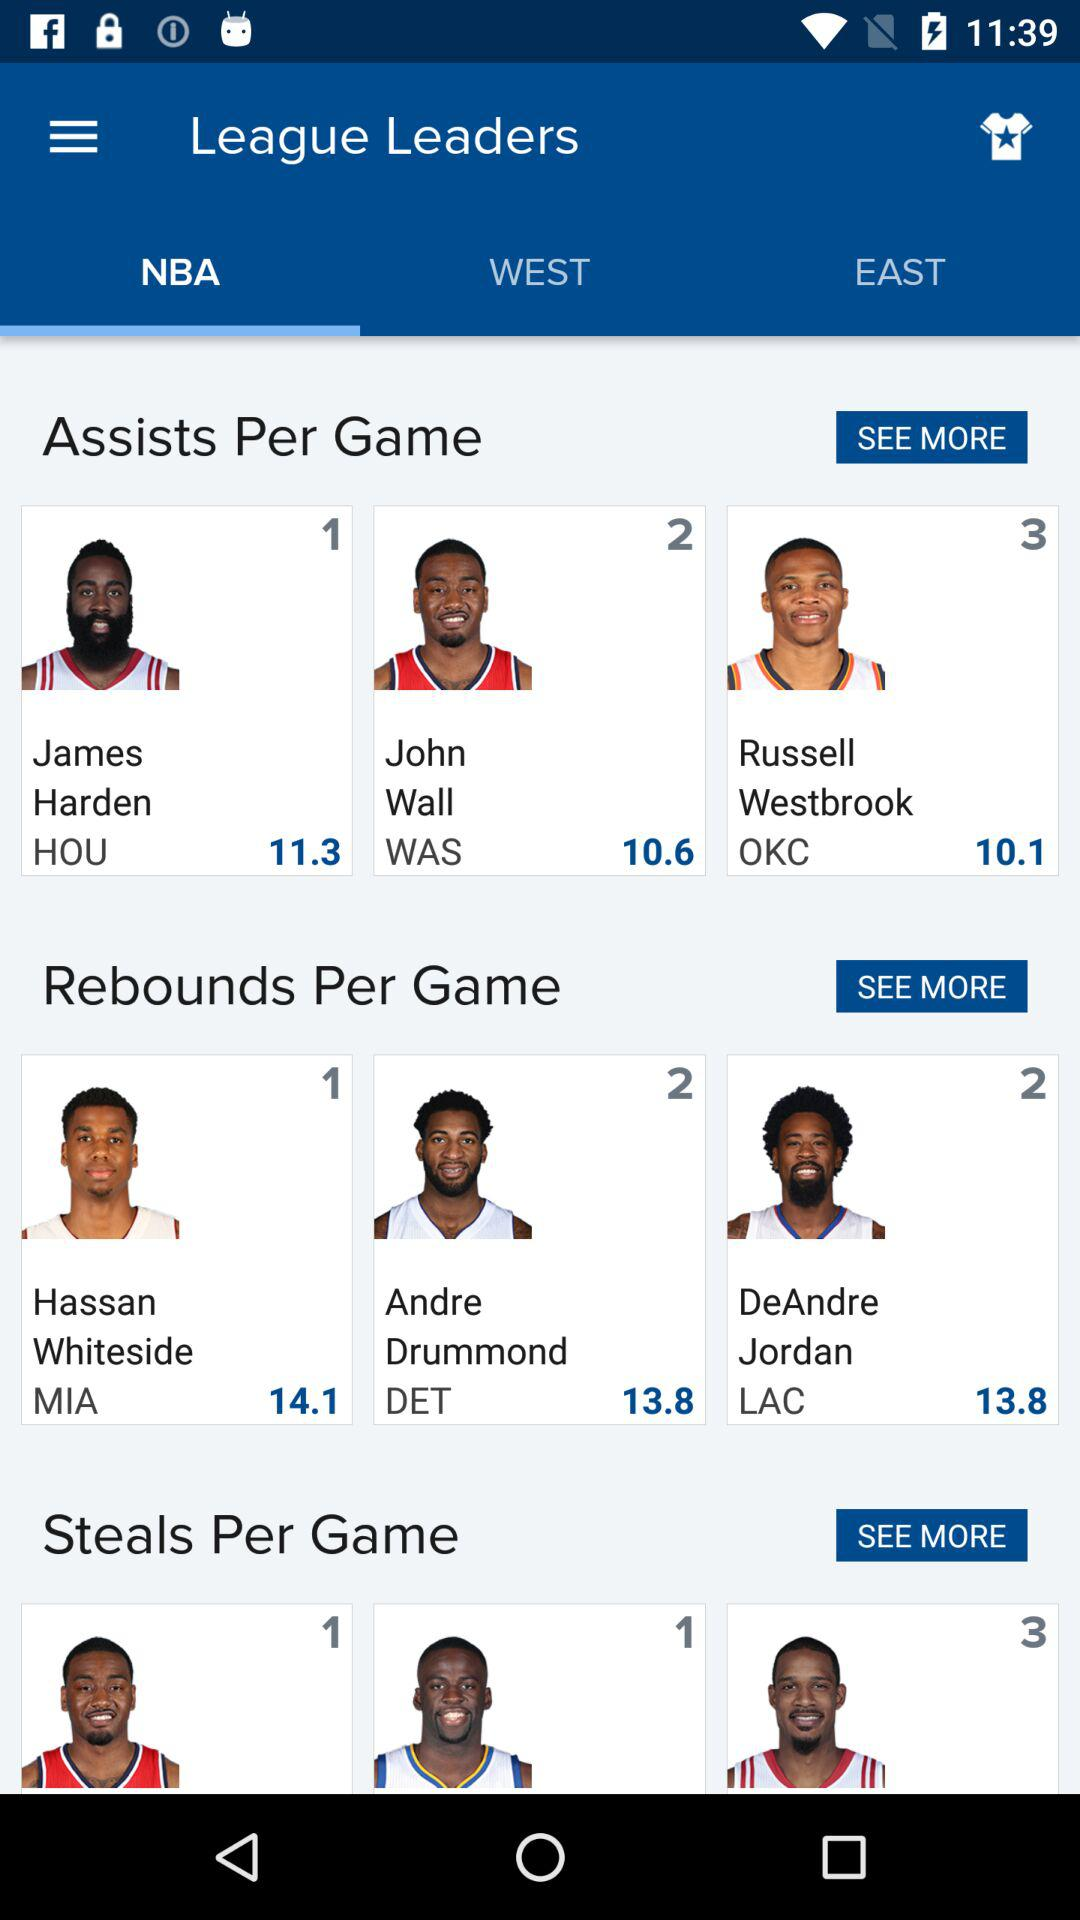How many points does James Harden have? James Harden has 11.3 points. 